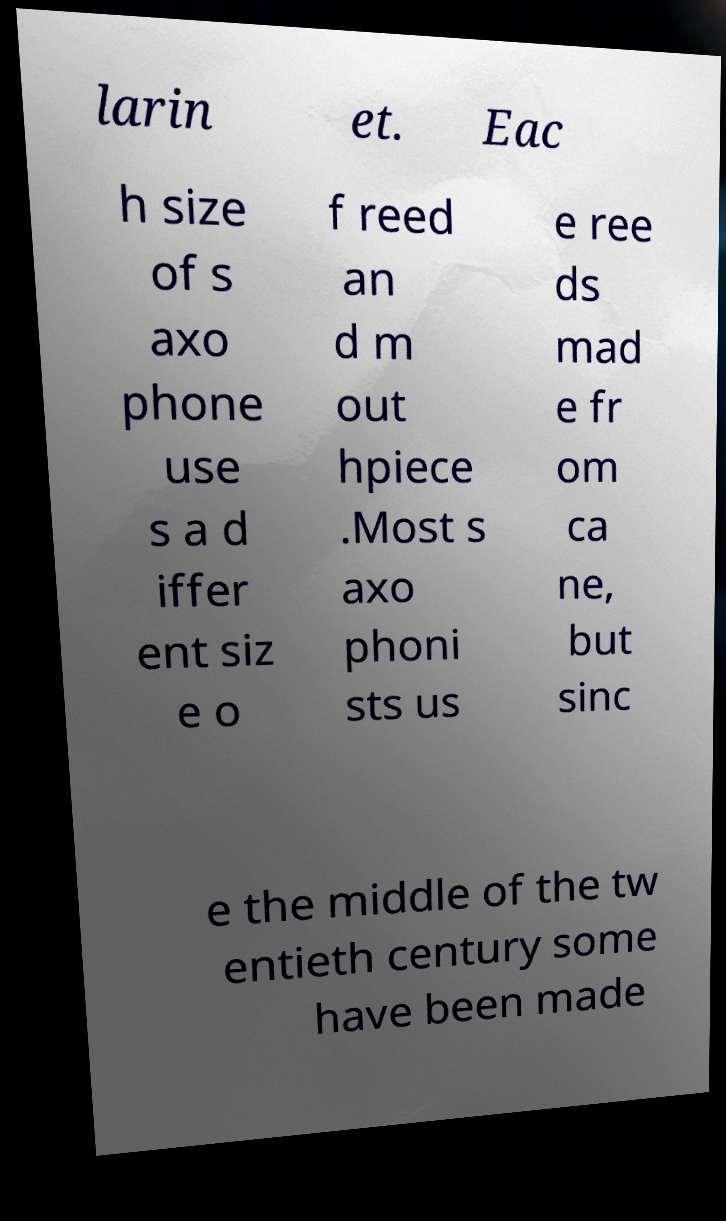Could you assist in decoding the text presented in this image and type it out clearly? larin et. Eac h size of s axo phone use s a d iffer ent siz e o f reed an d m out hpiece .Most s axo phoni sts us e ree ds mad e fr om ca ne, but sinc e the middle of the tw entieth century some have been made 